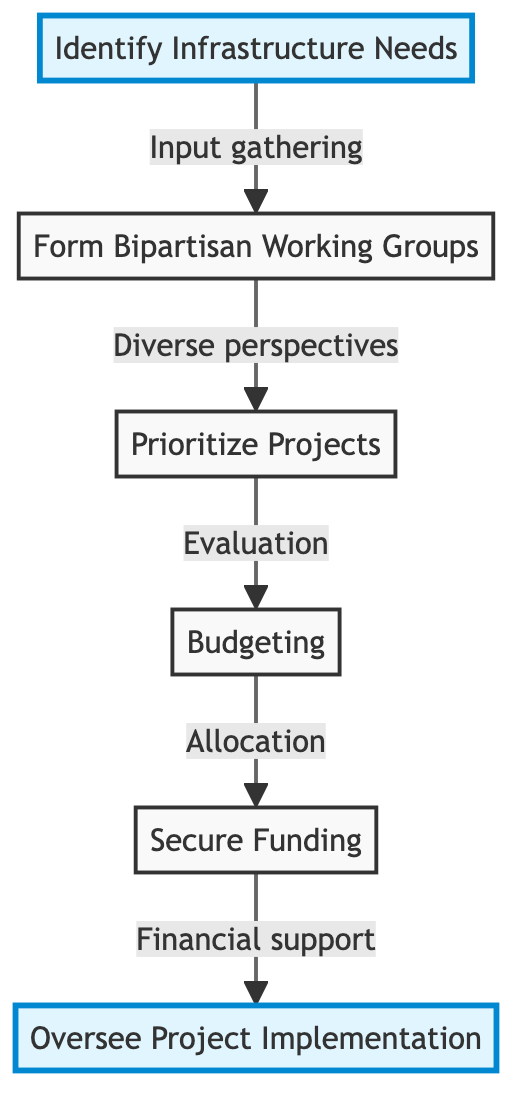What is the first step in the process? The flow chart indicates that the first step is "Identify Infrastructure Needs." This is where input is gathered from various stakeholders to find pressing infrastructure requirements.
Answer: Identify Infrastructure Needs How many steps are in the flow chart? The flow chart contains a total of six steps: Identify Infrastructure Needs, Form Bipartisan Working Groups, Prioritize Projects, Budgeting, Secure Funding, and Oversee Project Implementation.
Answer: 6 Which two steps are directly connected? The steps "Identify Infrastructure Needs" and "Form Bipartisan Working Groups" are directly connected, with an arrow indicating that input gathered leads to forming these groups.
Answer: Identify Infrastructure Needs and Form Bipartisan Working Groups What is the main goal after "Budgeting"? The main goal after "Budgeting" is "Secure Funding," as depicted by the arrow pointing from Budgeting to Secure Funding. This indicates that budgeting facilitates the ability to secure the necessary financial support.
Answer: Secure Funding What role do bipartisan working groups play in project prioritization? Bipartisan working groups provide diverse perspectives that are used during the "Prioritize Projects" step to evaluate potential projects based on various factors such as public safety and economic impact.
Answer: Diverse perspectives What connects "Prioritize Projects" to "Budgeting"? The flow chart shows an arrow flowing from "Prioritize Projects" to "Budgeting," indicating that project evaluation leads to developing a comprehensive budget plan.
Answer: Evaluation Explain the significance of oversight committees during project implementation. Oversight committees are composed of bipartisan representatives and play a crucial role in the "Oversee Project Implementation" step by ensuring adherence to timelines, budgets, and quality standards during the execution of the projects.
Answer: Ensure adherence to timelines, budgets, and quality standards Which step involves gathering input from various stakeholders? The step "Identify Infrastructure Needs" explicitly details the gathering of input from state and local officials, industry leaders, and the public regarding infrastructure requirements.
Answer: Identify Infrastructure Needs What comes after securing funding in the process? After "Secure Funding," the next step indicated in the flow chart is "Oversee Project Implementation," which focuses on the actual execution of the projects once funding is secured.
Answer: Oversee Project Implementation What is a key consideration when prioritizing projects? A key consideration when prioritizing projects is "public safety," among other factors such as economic impact and environmental sustainability, which are highlighted in the description of the "Prioritize Projects" step.
Answer: Public safety 